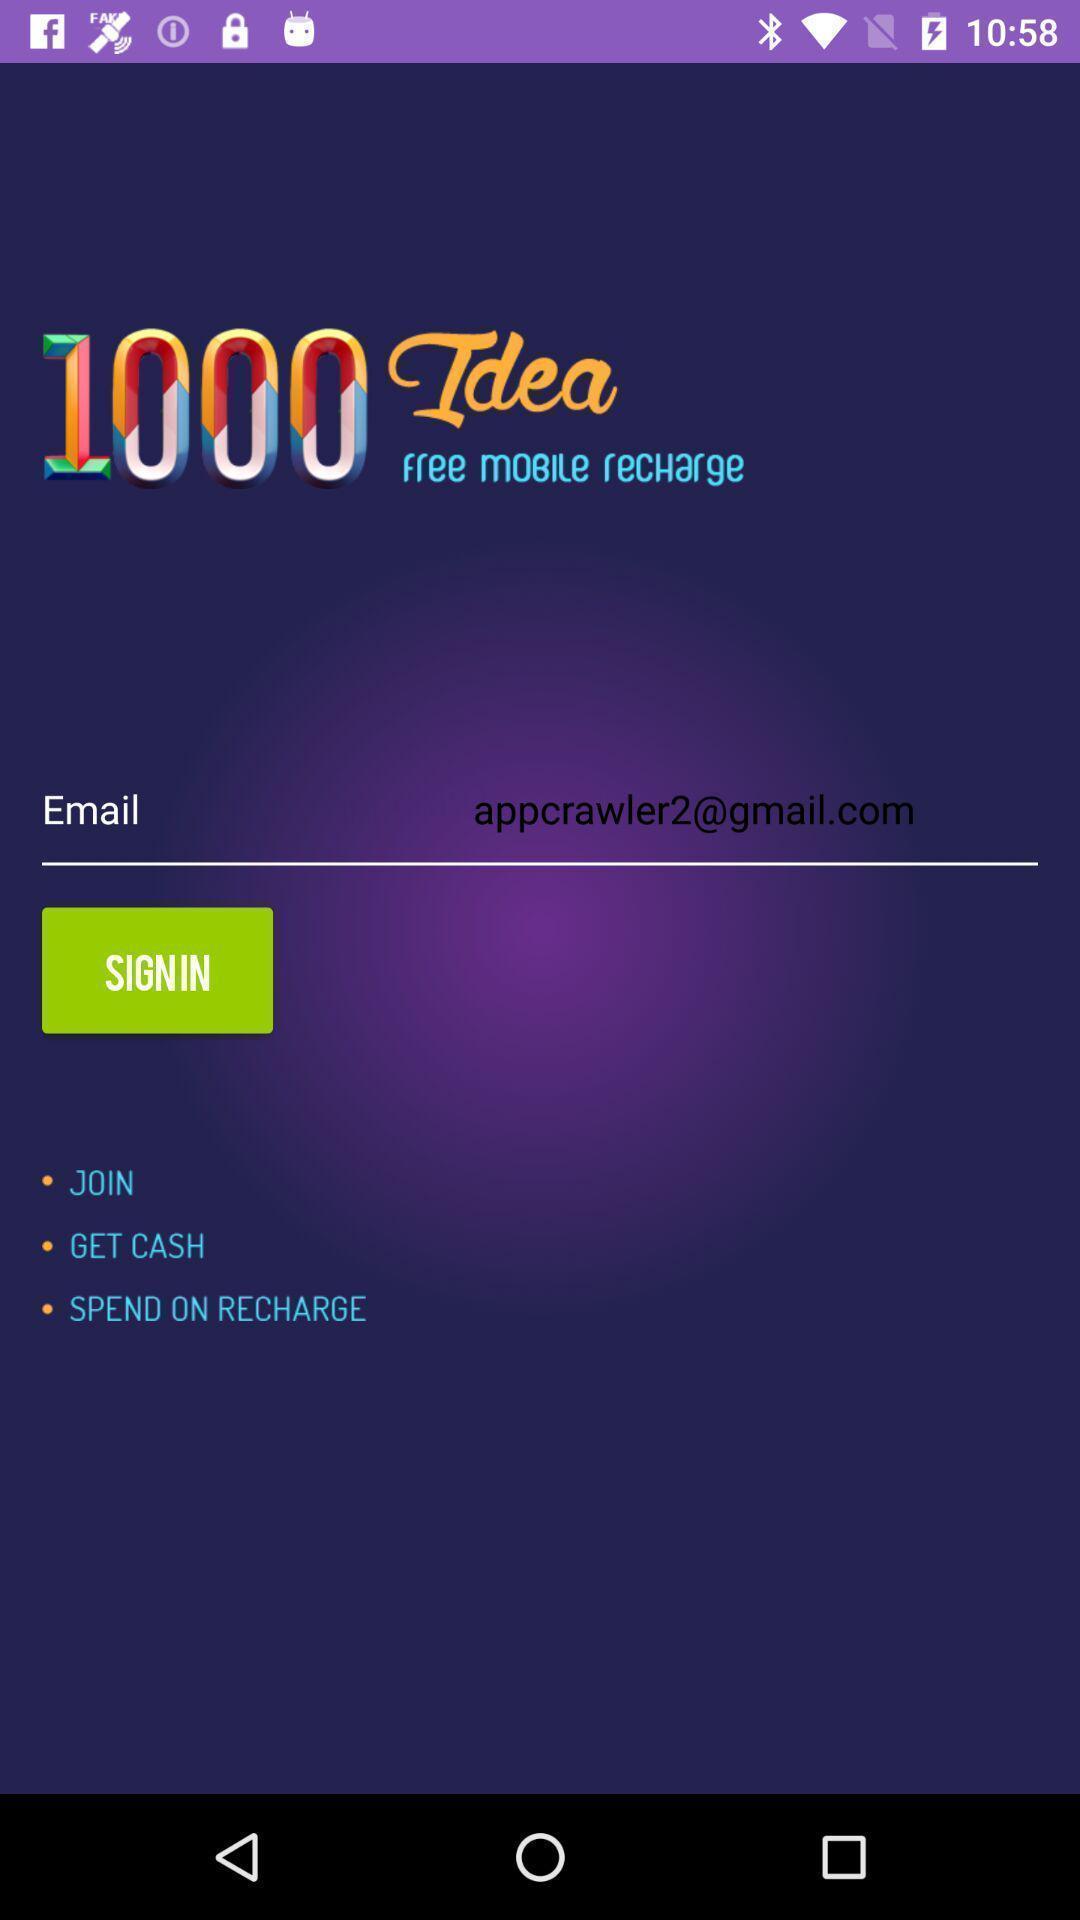Please provide a description for this image. Sign in page. 